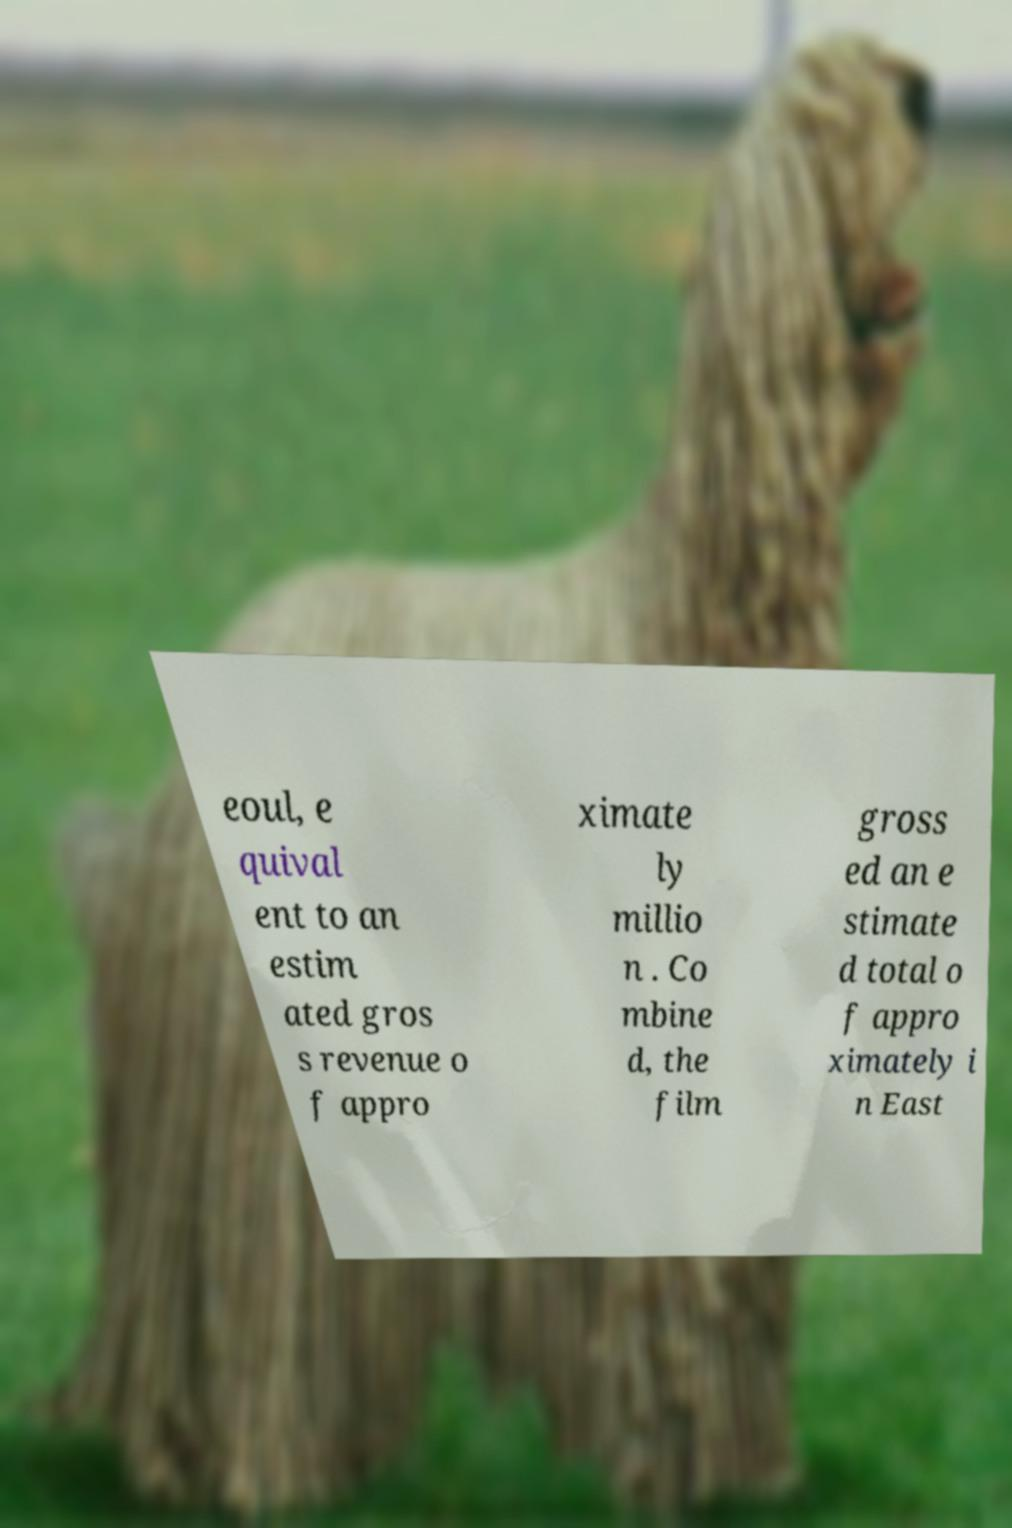Can you accurately transcribe the text from the provided image for me? eoul, e quival ent to an estim ated gros s revenue o f appro ximate ly millio n . Co mbine d, the film gross ed an e stimate d total o f appro ximately i n East 